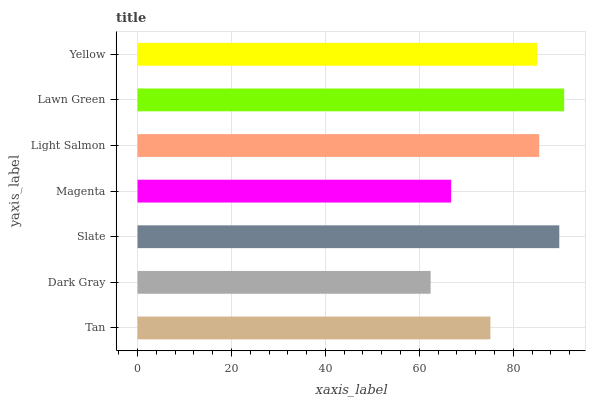Is Dark Gray the minimum?
Answer yes or no. Yes. Is Lawn Green the maximum?
Answer yes or no. Yes. Is Slate the minimum?
Answer yes or no. No. Is Slate the maximum?
Answer yes or no. No. Is Slate greater than Dark Gray?
Answer yes or no. Yes. Is Dark Gray less than Slate?
Answer yes or no. Yes. Is Dark Gray greater than Slate?
Answer yes or no. No. Is Slate less than Dark Gray?
Answer yes or no. No. Is Yellow the high median?
Answer yes or no. Yes. Is Yellow the low median?
Answer yes or no. Yes. Is Lawn Green the high median?
Answer yes or no. No. Is Tan the low median?
Answer yes or no. No. 